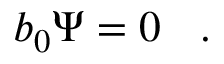Convert formula to latex. <formula><loc_0><loc_0><loc_500><loc_500>b _ { 0 } \Psi = 0 \ .</formula> 